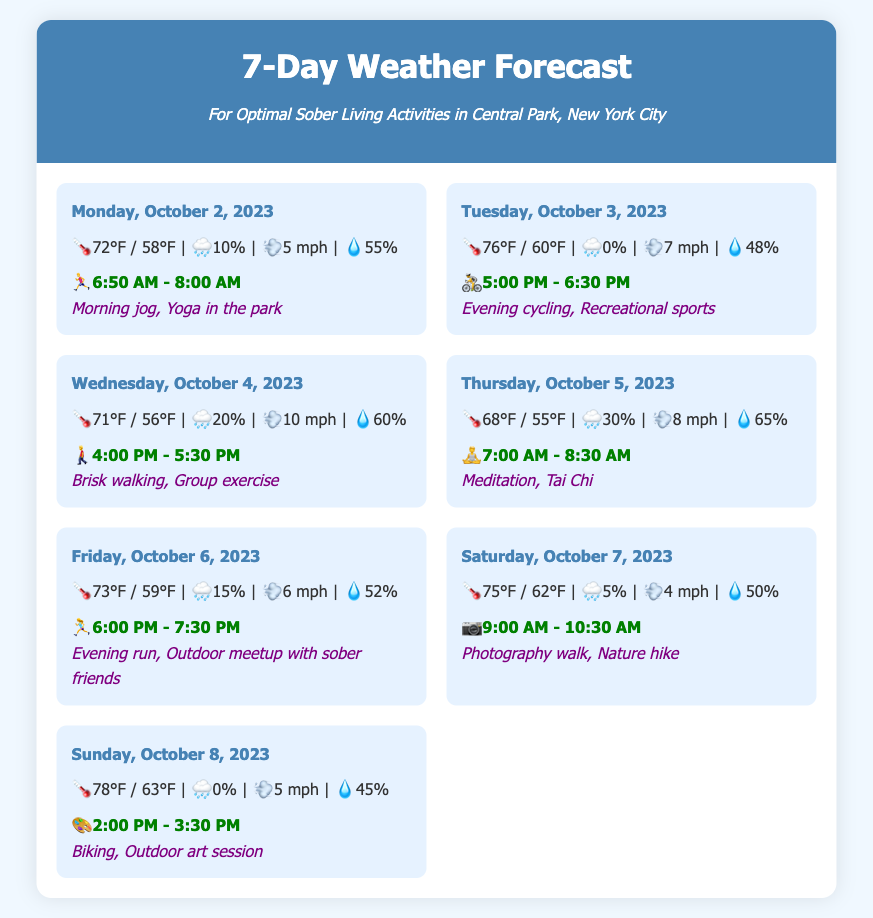What is the date for the weather forecast? The date for the weather forecast is displayed prominently at the top of the weather cards. All dates are from October 2 to October 8, 2023.
Answer: October 2 to October 8, 2023 What is the temperature on Tuesday, October 3, 2023? The temperature is represented as a range in the weather card for each day. For Tuesday, it is 76°F / 60°F.
Answer: 76°F / 60°F When is the optimal time for a morning jog? The optimal time for a morning jog is listed under the hobby time section for Monday.
Answer: 6:50 AM - 8:00 AM What is the wind speed on Wednesday? The wind speed is indicated in the weather information for Wednesday and is given in miles per hour.
Answer: 10 mph Which day's weather report suggests "Meditation, Tai Chi"? This suggestion is found in the weather card for Thursday, which includes activities suitable for that day's forecast.
Answer: Thursday, October 5, 2023 On what day is the chance of rain 0%? The chance of rain is indicated in the weather information, and it is 0% on both Tuesday and Sunday.
Answer: Tuesday and Sunday What recreational activity is recommended on Saturday? The hobby suggestion for Saturday includes specific outdoor activities that can be enjoyed in the weather conditions.
Answer: Photography walk, Nature hike What is the humidity level on Friday? The humidity percentage is provided in the weather information for each day, including that for Friday.
Answer: 52% What is the suggested time for outdoor art sessions? The time recommended for outdoor activities like an art session is noted in the hobby time section for Sunday.
Answer: 2:00 PM - 3:30 PM 